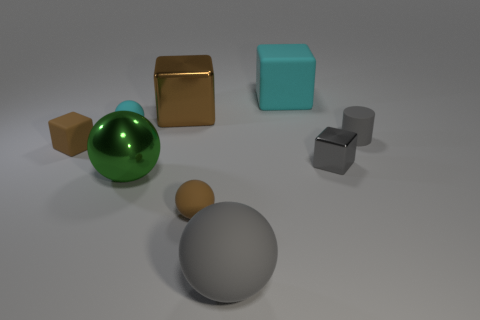Add 1 big blue matte cylinders. How many objects exist? 10 Subtract all cubes. How many objects are left? 5 Subtract all small cyan rubber spheres. Subtract all cyan rubber balls. How many objects are left? 7 Add 8 cyan rubber objects. How many cyan rubber objects are left? 10 Add 9 small brown matte spheres. How many small brown matte spheres exist? 10 Subtract 0 red spheres. How many objects are left? 9 